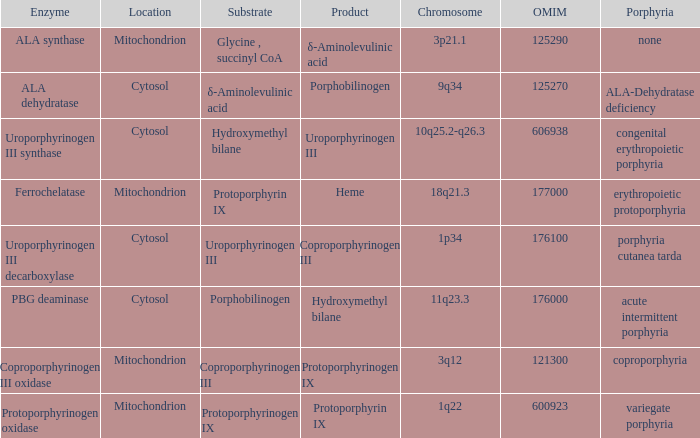What is protoporphyrin ix's substrate? Protoporphyrinogen IX. 